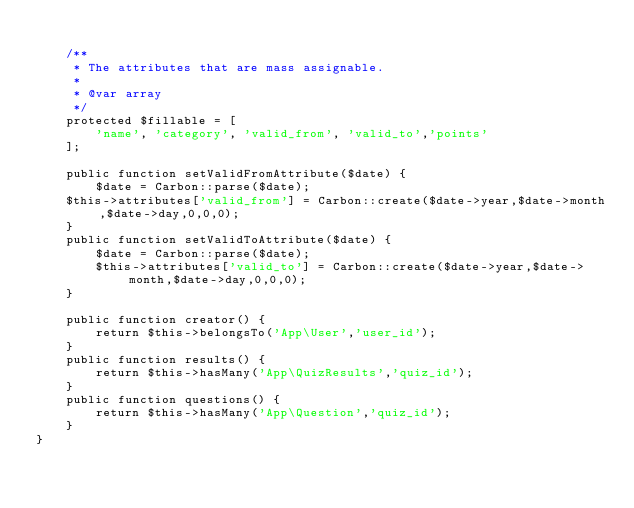Convert code to text. <code><loc_0><loc_0><loc_500><loc_500><_PHP_>
    /**
     * The attributes that are mass assignable.
     *
     * @var array
     */
    protected $fillable = [
        'name', 'category', 'valid_from', 'valid_to','points'
    ];

    public function setValidFromAttribute($date) {
        $date = Carbon::parse($date);
    $this->attributes['valid_from'] = Carbon::create($date->year,$date->month,$date->day,0,0,0);
    }
    public function setValidToAttribute($date) {
        $date = Carbon::parse($date);
        $this->attributes['valid_to'] = Carbon::create($date->year,$date->month,$date->day,0,0,0);
    }

    public function creator() {
        return $this->belongsTo('App\User','user_id');
    }
    public function results() {
        return $this->hasMany('App\QuizResults','quiz_id');
    }
    public function questions() {
        return $this->hasMany('App\Question','quiz_id');
    }
}
</code> 